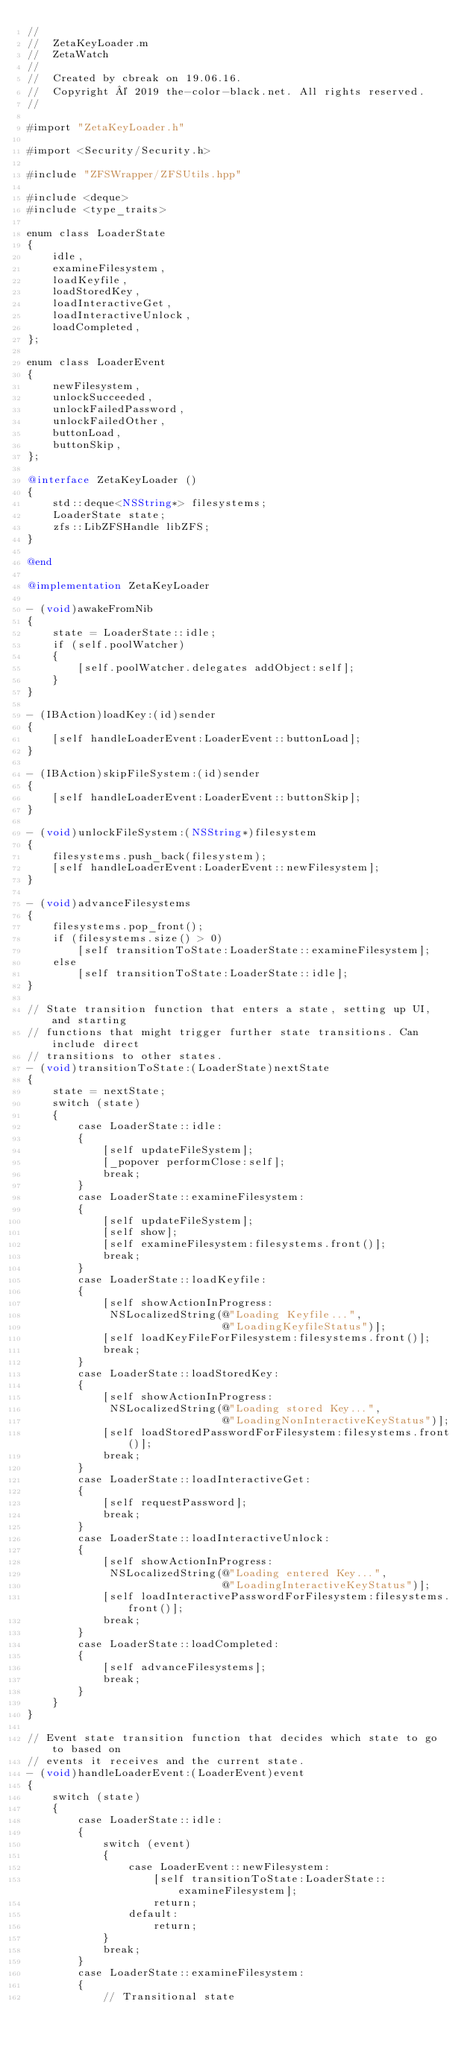<code> <loc_0><loc_0><loc_500><loc_500><_ObjectiveC_>//
//  ZetaKeyLoader.m
//  ZetaWatch
//
//  Created by cbreak on 19.06.16.
//  Copyright © 2019 the-color-black.net. All rights reserved.
//

#import "ZetaKeyLoader.h"

#import <Security/Security.h>

#include "ZFSWrapper/ZFSUtils.hpp"

#include <deque>
#include <type_traits>

enum class LoaderState
{
	idle,
	examineFilesystem,
	loadKeyfile,
	loadStoredKey,
	loadInteractiveGet,
	loadInteractiveUnlock,
	loadCompleted,
};

enum class LoaderEvent
{
	newFilesystem,
	unlockSucceeded,
	unlockFailedPassword,
	unlockFailedOther,
	buttonLoad,
	buttonSkip,
};

@interface ZetaKeyLoader ()
{
	std::deque<NSString*> filesystems;
	LoaderState state;
	zfs::LibZFSHandle libZFS;
}

@end

@implementation ZetaKeyLoader

- (void)awakeFromNib
{
	state = LoaderState::idle;
	if (self.poolWatcher)
	{
		[self.poolWatcher.delegates addObject:self];
	}
}

- (IBAction)loadKey:(id)sender
{
	[self handleLoaderEvent:LoaderEvent::buttonLoad];
}

- (IBAction)skipFileSystem:(id)sender
{
	[self handleLoaderEvent:LoaderEvent::buttonSkip];
}

- (void)unlockFileSystem:(NSString*)filesystem
{
	filesystems.push_back(filesystem);
	[self handleLoaderEvent:LoaderEvent::newFilesystem];
}

- (void)advanceFilesystems
{
	filesystems.pop_front();
	if (filesystems.size() > 0)
		[self transitionToState:LoaderState::examineFilesystem];
	else
		[self transitionToState:LoaderState::idle];
}

// State transition function that enters a state, setting up UI, and starting
// functions that might trigger further state transitions. Can include direct
// transitions to other states.
- (void)transitionToState:(LoaderState)nextState
{
	state = nextState;
	switch (state)
	{
		case LoaderState::idle:
		{
			[self updateFileSystem];
			[_popover performClose:self];
			break;
		}
		case LoaderState::examineFilesystem:
		{
			[self updateFileSystem];
			[self show];
			[self examineFilesystem:filesystems.front()];
			break;
		}
		case LoaderState::loadKeyfile:
		{
			[self showActionInProgress:
			 NSLocalizedString(@"Loading Keyfile...",
							   @"LoadingKeyfileStatus")];
			[self loadKeyFileForFilesystem:filesystems.front()];
			break;
		}
		case LoaderState::loadStoredKey:
		{
			[self showActionInProgress:
			 NSLocalizedString(@"Loading stored Key...",
							   @"LoadingNonInteractiveKeyStatus")];
			[self loadStoredPasswordForFilesystem:filesystems.front()];
			break;
		}
		case LoaderState::loadInteractiveGet:
		{
			[self requestPassword];
			break;
		}
		case LoaderState::loadInteractiveUnlock:
		{
			[self showActionInProgress:
			 NSLocalizedString(@"Loading entered Key...",
							   @"LoadingInteractiveKeyStatus")];
			[self loadInteractivePasswordForFilesystem:filesystems.front()];
			break;
		}
		case LoaderState::loadCompleted:
		{
			[self advanceFilesystems];
			break;
		}
	}
}

// Event state transition function that decides which state to go to based on
// events it receives and the current state.
- (void)handleLoaderEvent:(LoaderEvent)event
{
	switch (state)
	{
		case LoaderState::idle:
		{
			switch (event)
			{
				case LoaderEvent::newFilesystem:
					[self transitionToState:LoaderState::examineFilesystem];
					return;
				default:
					return;
			}
			break;
		}
		case LoaderState::examineFilesystem:
		{
			// Transitional state</code> 